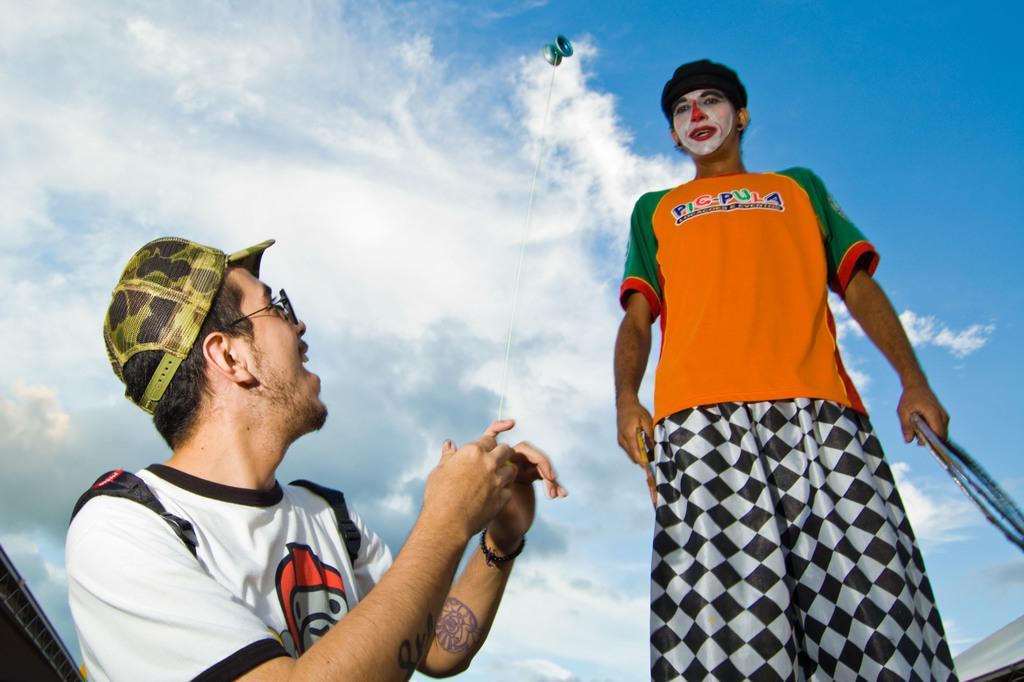Describe this image in one or two sentences. In the image two persons are standing and holding some objects and he is holding a thread. At the top of the image we can see some clouds in the sky. 